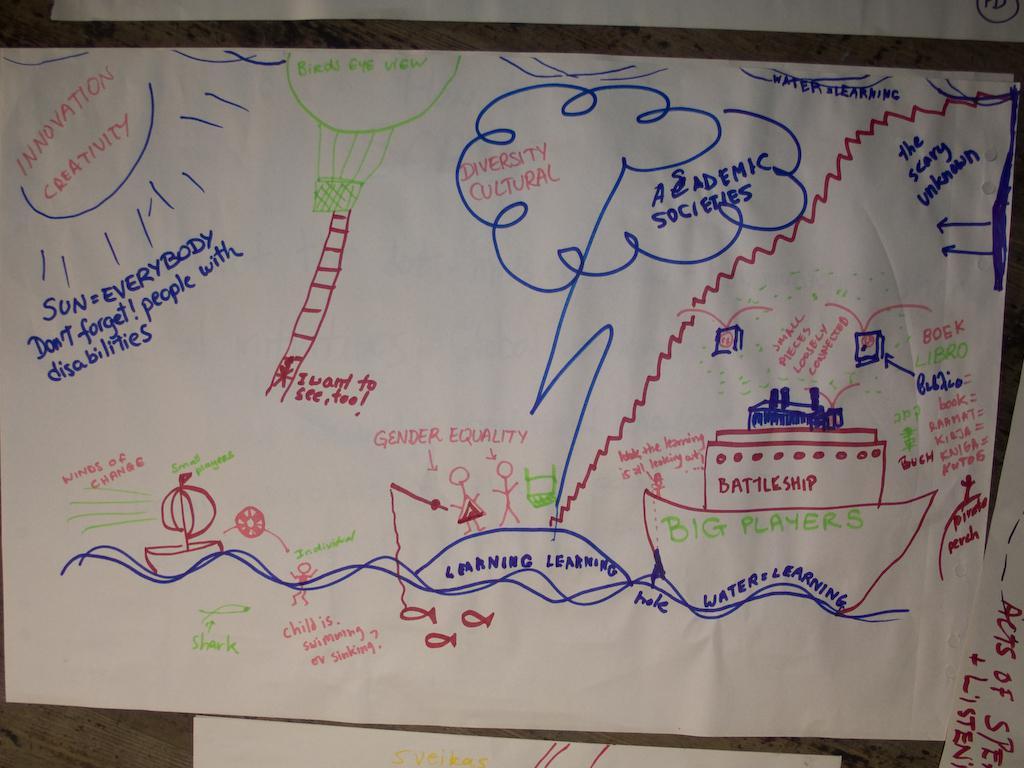What does the battleship represent, written in green?
Keep it short and to the point. Big players. What is written in the sun?
Provide a succinct answer. Innovation creativity. 